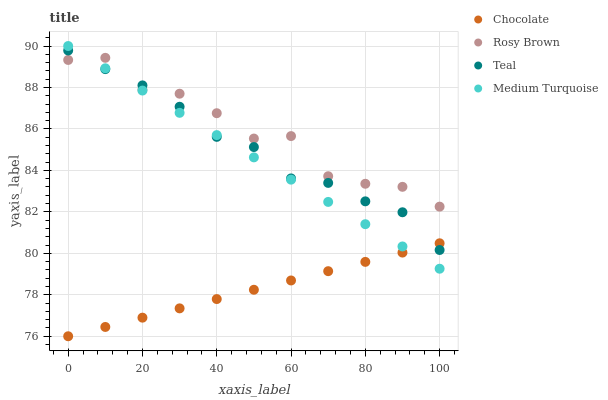Does Chocolate have the minimum area under the curve?
Answer yes or no. Yes. Does Rosy Brown have the maximum area under the curve?
Answer yes or no. Yes. Does Medium Turquoise have the minimum area under the curve?
Answer yes or no. No. Does Medium Turquoise have the maximum area under the curve?
Answer yes or no. No. Is Medium Turquoise the smoothest?
Answer yes or no. Yes. Is Rosy Brown the roughest?
Answer yes or no. Yes. Is Teal the smoothest?
Answer yes or no. No. Is Teal the roughest?
Answer yes or no. No. Does Chocolate have the lowest value?
Answer yes or no. Yes. Does Medium Turquoise have the lowest value?
Answer yes or no. No. Does Medium Turquoise have the highest value?
Answer yes or no. Yes. Does Teal have the highest value?
Answer yes or no. No. Is Chocolate less than Rosy Brown?
Answer yes or no. Yes. Is Rosy Brown greater than Chocolate?
Answer yes or no. Yes. Does Teal intersect Medium Turquoise?
Answer yes or no. Yes. Is Teal less than Medium Turquoise?
Answer yes or no. No. Is Teal greater than Medium Turquoise?
Answer yes or no. No. Does Chocolate intersect Rosy Brown?
Answer yes or no. No. 